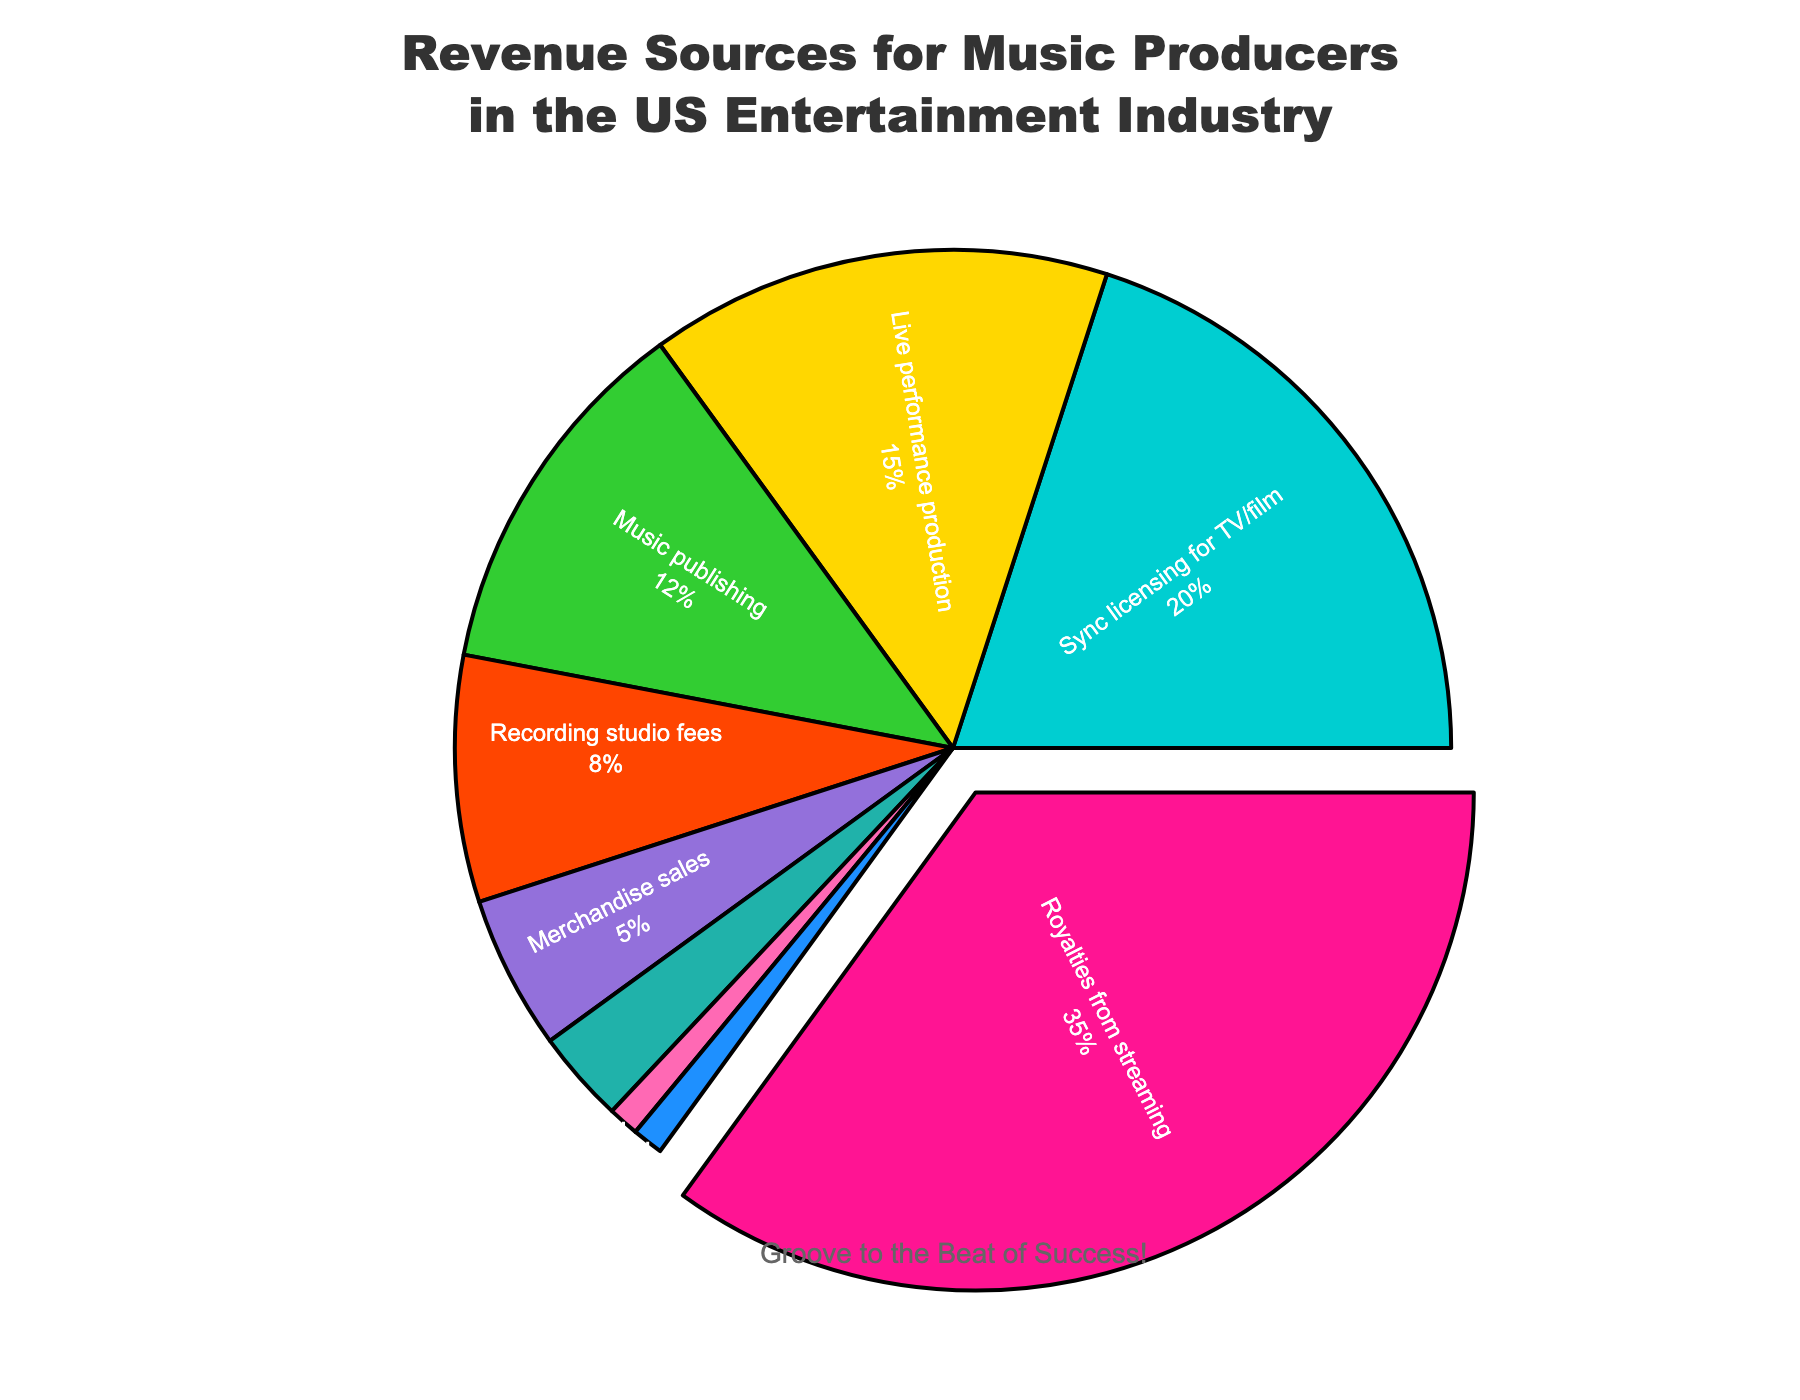What is the largest revenue source for music producers in the US entertainment industry? The largest revenue source can be determined by identifying the segment with the highest percentage value on the pie chart. The "Royalties from streaming" segment is noticeably pulled out from the pie and it shows 35% which is the highest value.
Answer: Royalties from streaming Which category contributes more to the revenue: Live performance production or Music publishing? To find which category contributes more revenue, compare the percentages of "Live performance production" and "Music publishing". "Live performance production" is 15% and "Music publishing" is 12%. Therefore, "Live performance production" contributes more.
Answer: Live performance production What is the combined percentage of revenue from Sync licensing for TV/film and Recording studio fees? Add the percentages of "Sync licensing for TV/film" (20%) and "Recording studio fees" (8%). The combined percentage is 20% + 8% = 28%.
Answer: 28% Out of Merchandise sales, Digital download sales, and Physical album sales, which category contributes the least to the revenue? Compare the percentages of "Merchandise sales" (5%), "Digital download sales" (3%), and "Physical album sales" (1%). The category with the smallest percentage is "Physical album sales" with 1%.
Answer: Physical album sales By how much does the percentage of revenue from Royalties from streaming exceed the percentage from Music publishing? Subtract the percentage of "Music publishing" (12%) from "Royalties from streaming" (35%). The difference is 35% - 12% = 23%.
Answer: 23% Which color represents the Music publishing category on the pie chart? Locate the segment for "Music publishing" and note its color on the chart, which is likely styled consistently with code's definition. The "Music publishing" is represented by a segment colored in a shade corresponding to its position in the `colors` array, #32CD32 which is green.
Answer: Green What is the difference in revenue percentage between Sync licensing for TV/film and Brand partnerships? Subtract the percentage of "Brand partnerships" (1%) from "Sync licensing for TV/film" (20%). The difference is 20% - 1% = 19%.
Answer: 19% What visual cue indicates the top revenue source in this chart? Identify the visual features of the pie chart. The top revenue source "Royalties from streaming" is visually pulled out from the rest of the pie segments.
Answer: Pulled out segment What is the share of revenue from categories contributing less than 5% each? Sum the percentages of categories with less than 5%. "Digital download sales" (3%), "Physical album sales" (1%), and "Brand partnerships" (1%). The total is 3% + 1% + 1% = 5%.
Answer: 5% How do the revenue percentages from Live performance production and Recording studio fees compare? Compare the percentages of "Live performance production" (15%) and "Recording studio fees" (8%). "Live performance production" has a higher percentage than "Recording studio fees".
Answer: Live performance production is higher 